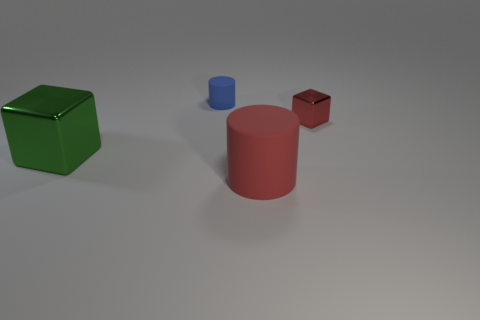Are there any other things that have the same material as the large cylinder?
Your response must be concise. Yes. What is the shape of the metallic thing behind the metallic cube to the left of the shiny thing that is on the right side of the big green thing?
Your response must be concise. Cube. How many other things are there of the same material as the large green cube?
Offer a terse response. 1. Are the cylinder in front of the tiny cylinder and the block that is in front of the red block made of the same material?
Your answer should be compact. No. How many objects are both behind the green metal cube and on the right side of the tiny blue rubber object?
Make the answer very short. 1. Is there a small red object that has the same shape as the big green metal object?
Ensure brevity in your answer.  Yes. What is the shape of the thing that is the same size as the blue matte cylinder?
Offer a very short reply. Cube. Are there an equal number of small rubber objects that are to the right of the large red object and metal blocks behind the blue rubber cylinder?
Your answer should be very brief. Yes. There is a metal thing that is to the right of the matte thing behind the red metal thing; how big is it?
Ensure brevity in your answer.  Small. Is there a brown matte ball that has the same size as the red cylinder?
Give a very brief answer. No. 